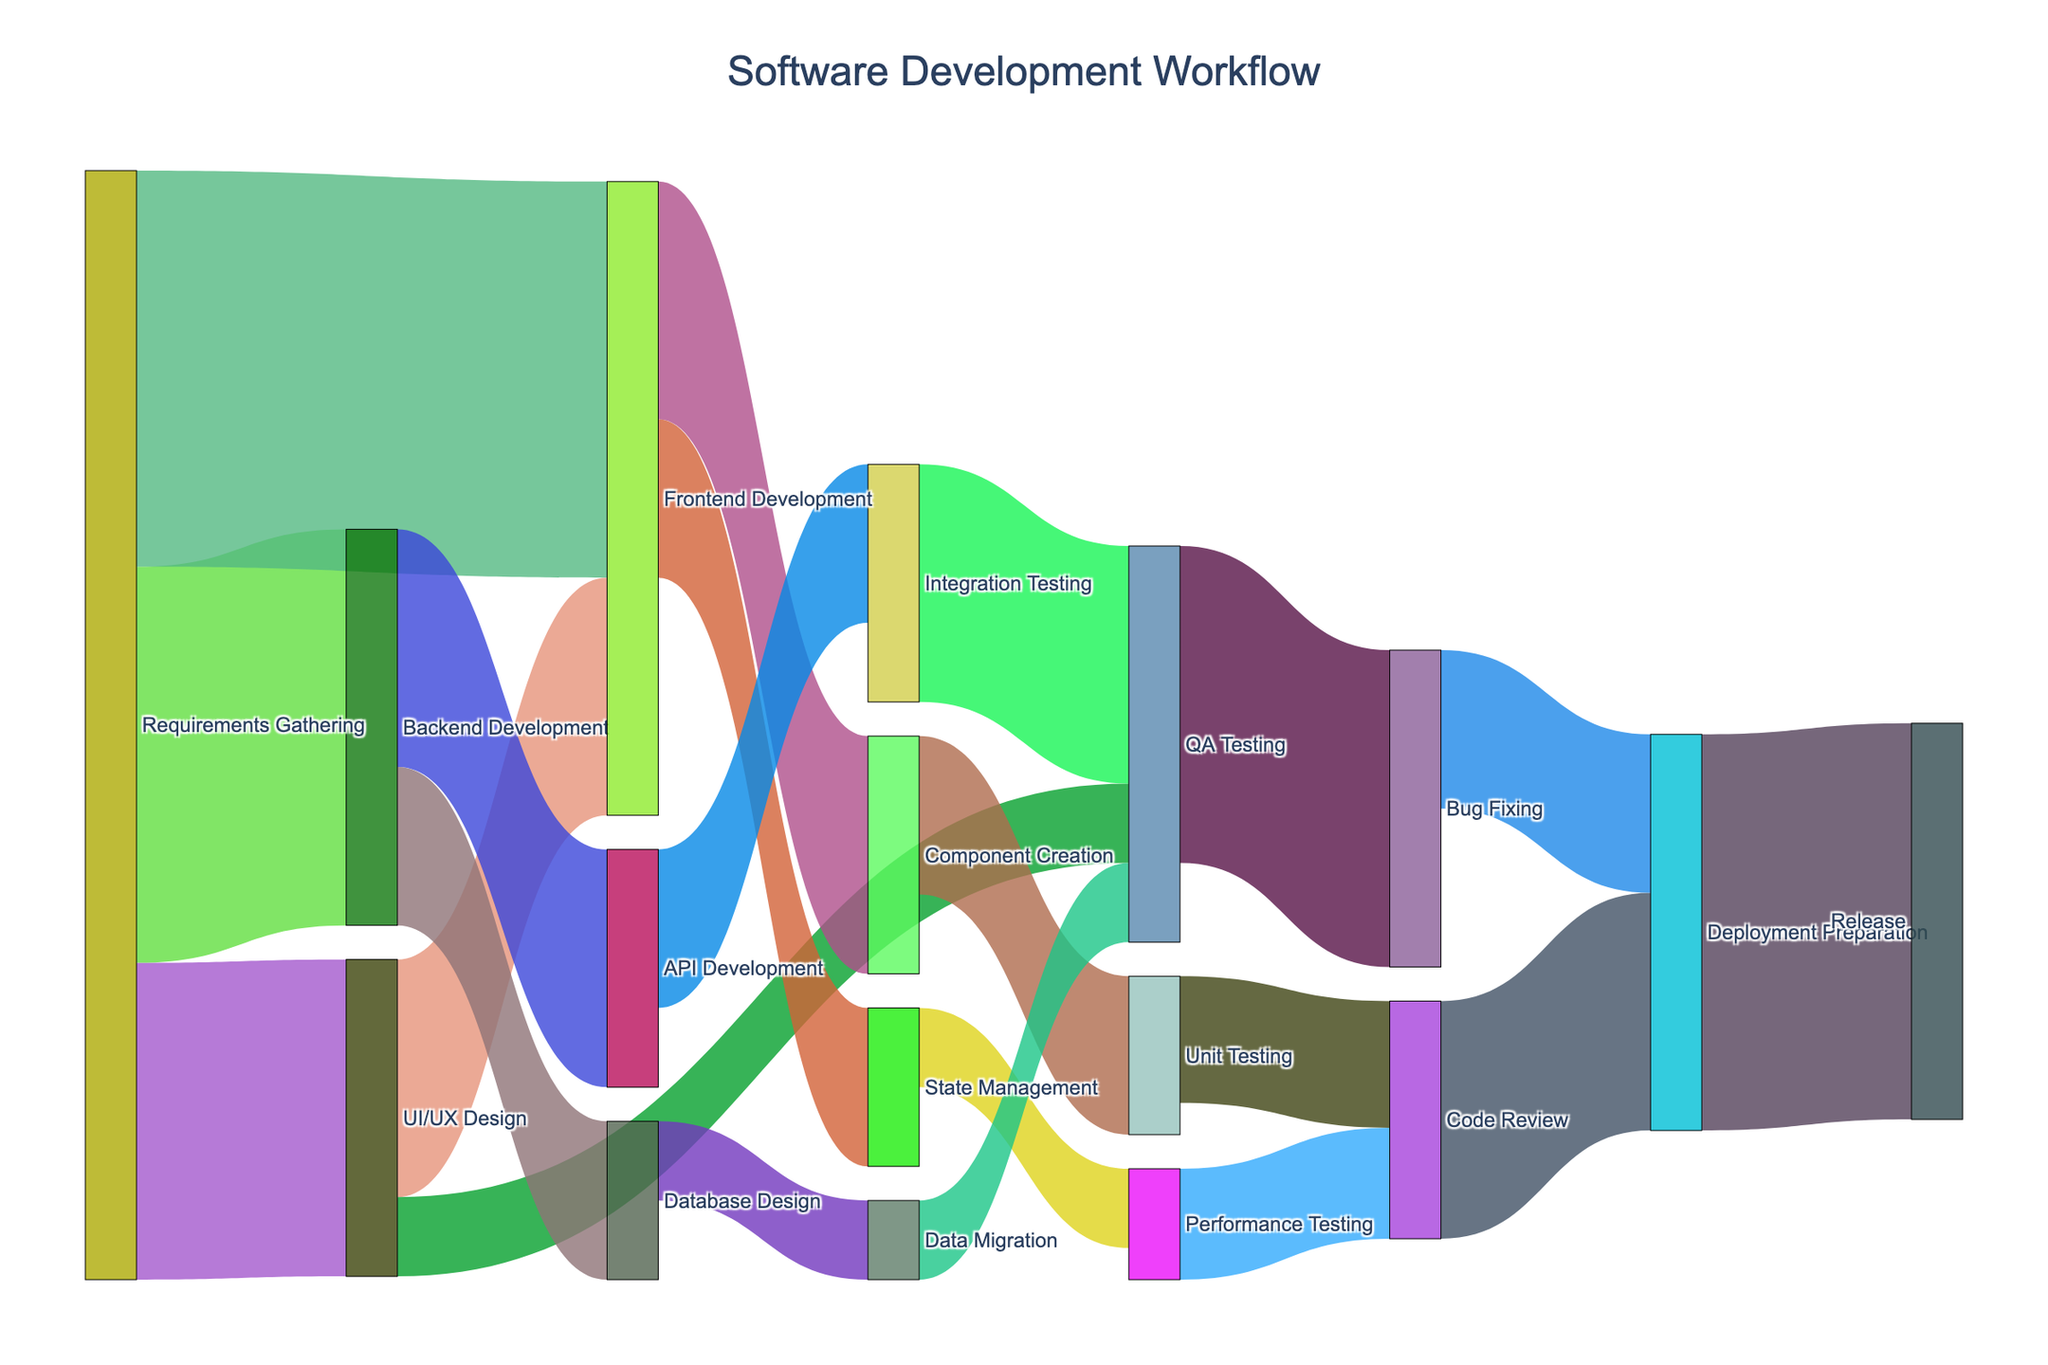What is the title of the figure? The title can be found at the top center of the Sankey diagram. It reads 'Software Development Workflow'.
Answer: Software Development Workflow How many different stages are depicted in the workflow? By counting the unique labels in the diagram, you can see there are 15 different stages.
Answer: 15 Which stage has the highest number of outgoing connections? The stage with the most outgoing arrows is 'Requirements Gathering' with three outgoing links leading to UI/UX Design, Backend Development, and Frontend Development.
Answer: Requirements Gathering What is the total value of tasks flowing from 'Frontend Development'? The flow from 'Frontend Development' splits into Component Creation (15) and State Management (10), so the total is 15 + 10 = 25.
Answer: 25 How many tasks flow directly into 'QA Testing'? By counting the incoming links to 'QA Testing', we see three flows: UI/UX Design (5), Integration Testing (15), and Data Migration (5).
Answer: 3 Compare the flows into 'Deployment Preparation' from 'Code Review' and 'Bug Fixing'. Which is greater? 'Code Review' flows into 'Deployment Preparation' with a value of 15, while 'Bug Fixing' flows into it with 10. Thus, 'Code Review's flow is greater.
Answer: Code Review If you add up the flows from 'UI/UX Design', what is the total value? The flows from 'UI/UX Design' consist of 15 to Frontend Development and 5 to QA Testing. Summing these gives 15 + 5 = 20.
Answer: 20 Which flow has the smallest value? After scanning all the values, 'Data Migration' to 'QA Testing' and 'State Management' to 'Performance Testing' have the smallest values, each with 5.
Answer: Data Migration to QA Testing and State Management to Performance Testing What's the total number of tasks that reach the 'Release' stage? The 'Release' stage has one incoming flow from 'Deployment Preparation' with a value of 25.
Answer: 25 Out of 'Component Creation' and 'State Management', which directly feeds into more stages? 'Component Creation' directly connects to 'Unit Testing', while 'State Management' connects to 'Performance Testing'. Both feed into only one stage each.
Answer: Both are equal 